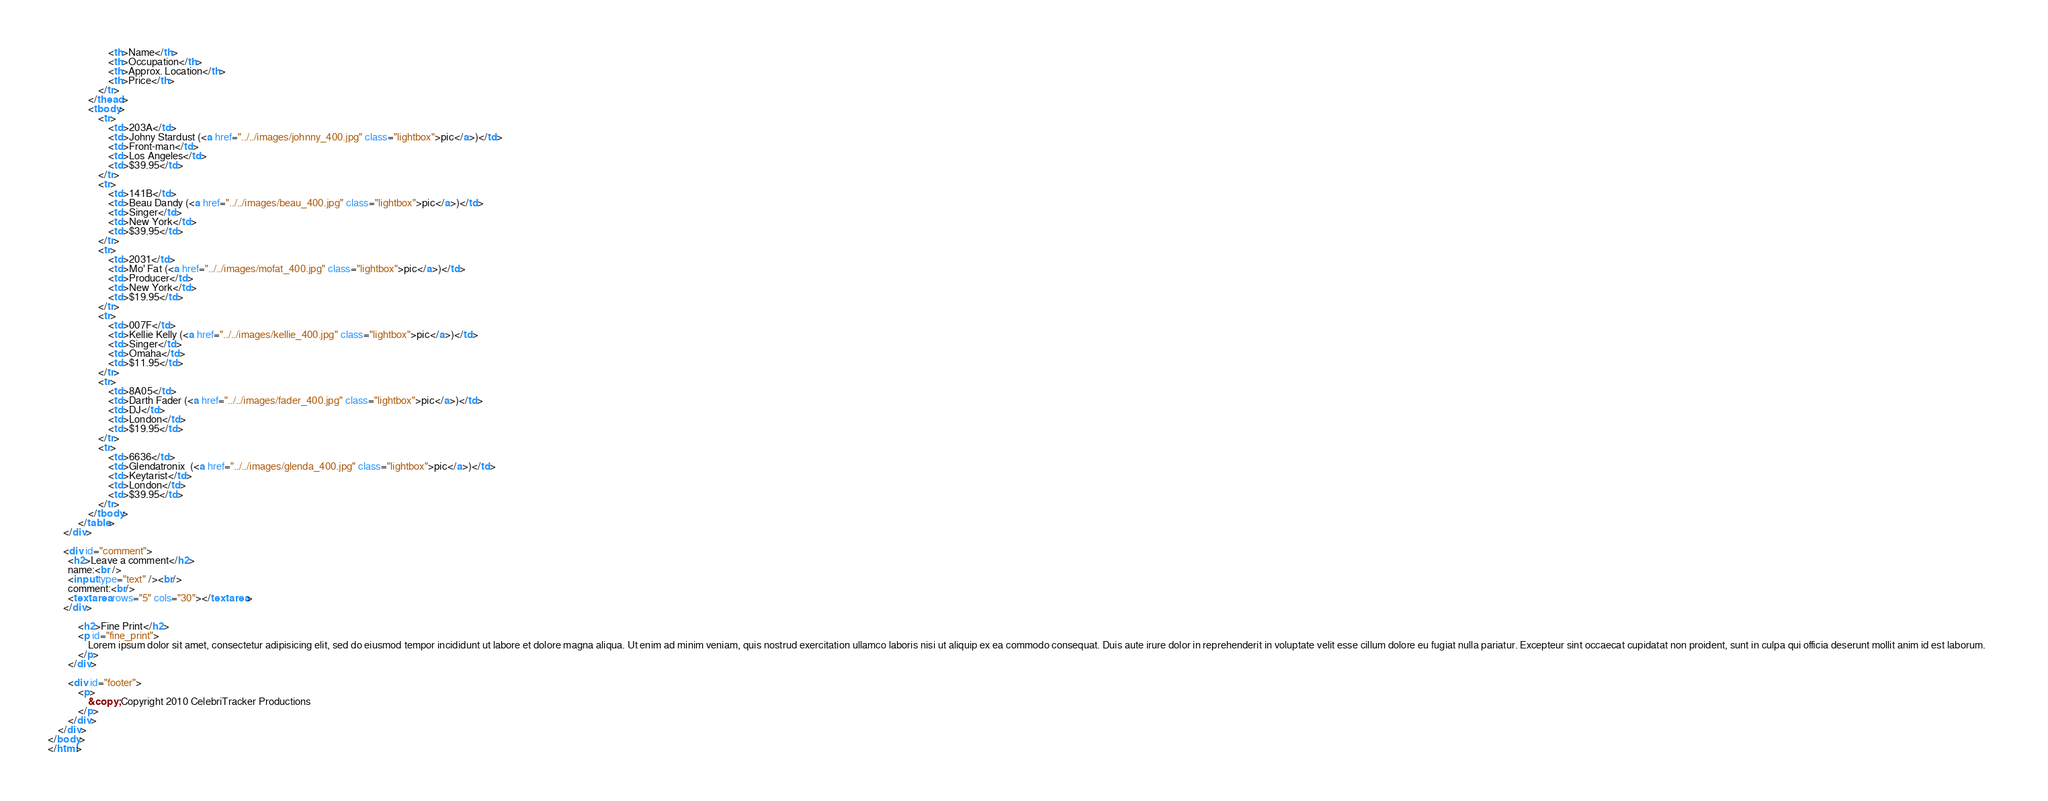Convert code to text. <code><loc_0><loc_0><loc_500><loc_500><_HTML_>  						<th>Name</th>
  						<th>Occupation</th>
  						<th>Approx. Location</th>
  						<th>Price</th>
  					</tr>
  				</thead>
  				<tbody>
  					<tr>
  						<td>203A</td>
  						<td>Johny Stardust (<a href="../../images/johnny_400.jpg" class="lightbox">pic</a>)</td>
  						<td>Front-man</td>
  						<td>Los Angeles</td>
  						<td>$39.95</td>
  					</tr>
  					<tr>
  						<td>141B</td>
  						<td>Beau Dandy (<a href="../../images/beau_400.jpg" class="lightbox">pic</a>)</td>
  						<td>Singer</td>
  						<td>New York</td>
  						<td>$39.95</td>
  					</tr>
  					<tr>
  						<td>2031</td>
  						<td>Mo' Fat (<a href="../../images/mofat_400.jpg" class="lightbox">pic</a>)</td>
  						<td>Producer</td>
  						<td>New York</td>
  						<td>$19.95</td>
  					</tr>
  					<tr>
  						<td>007F</td>
  						<td>Kellie Kelly (<a href="../../images/kellie_400.jpg" class="lightbox">pic</a>)</td>
  						<td>Singer</td>
  						<td>Omaha</td>
  						<td>$11.95</td>
  					</tr>
  					<tr>
  						<td>8A05</td>
  						<td>Darth Fader (<a href="../../images/fader_400.jpg" class="lightbox">pic</a>)</td>
  						<td>DJ</td>
  						<td>London</td>
  						<td>$19.95</td>
  					</tr>
  					<tr>
  						<td>6636</td>
  						<td>Glendatronix  (<a href="../../images/glenda_400.jpg" class="lightbox">pic</a>)</td>
  						<td>Keytarist</td>
  						<td>London</td>
  						<td>$39.95</td>
  					</tr>
  				</tbody>
  			</table>
      </div>
			
      <div id="comment">
        <h2>Leave a comment</h2>
        name:<br />
        <input type="text" /><br/>
        comment:<br/>
        <textarea rows="5" cols="30"></textarea>
      </div>
			
			<h2>Fine Print</h2>
			<p id="fine_print">
				Lorem ipsum dolor sit amet, consectetur adipisicing elit, sed do eiusmod tempor incididunt ut labore et dolore magna aliqua. Ut enim ad minim veniam, quis nostrud exercitation ullamco laboris nisi ut aliquip ex ea commodo consequat. Duis aute irure dolor in reprehenderit in voluptate velit esse cillum dolore eu fugiat nulla pariatur. Excepteur sint occaecat cupidatat non proident, sunt in culpa qui officia deserunt mollit anim id est laborum.		
			</p>
		</div>

		<div id="footer">
			<p>
				&copy; Copyright 2010 CelebriTracker Productions
			</p>
		</div>
	</div>
</body>
</html>
</code> 